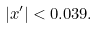Convert formula to latex. <formula><loc_0><loc_0><loc_500><loc_500>| x ^ { \prime } | < 0 . 0 3 9 .</formula> 